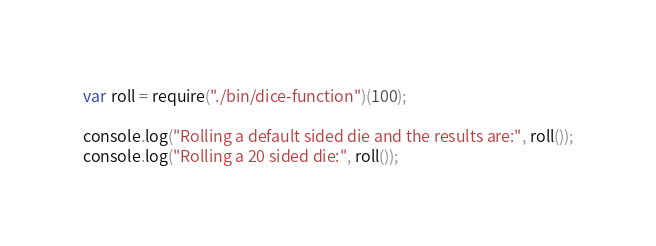<code> <loc_0><loc_0><loc_500><loc_500><_JavaScript_>var roll = require("./bin/dice-function")(100);

console.log("Rolling a default sided die and the results are:", roll());
console.log("Rolling a 20 sided die:", roll());
</code> 